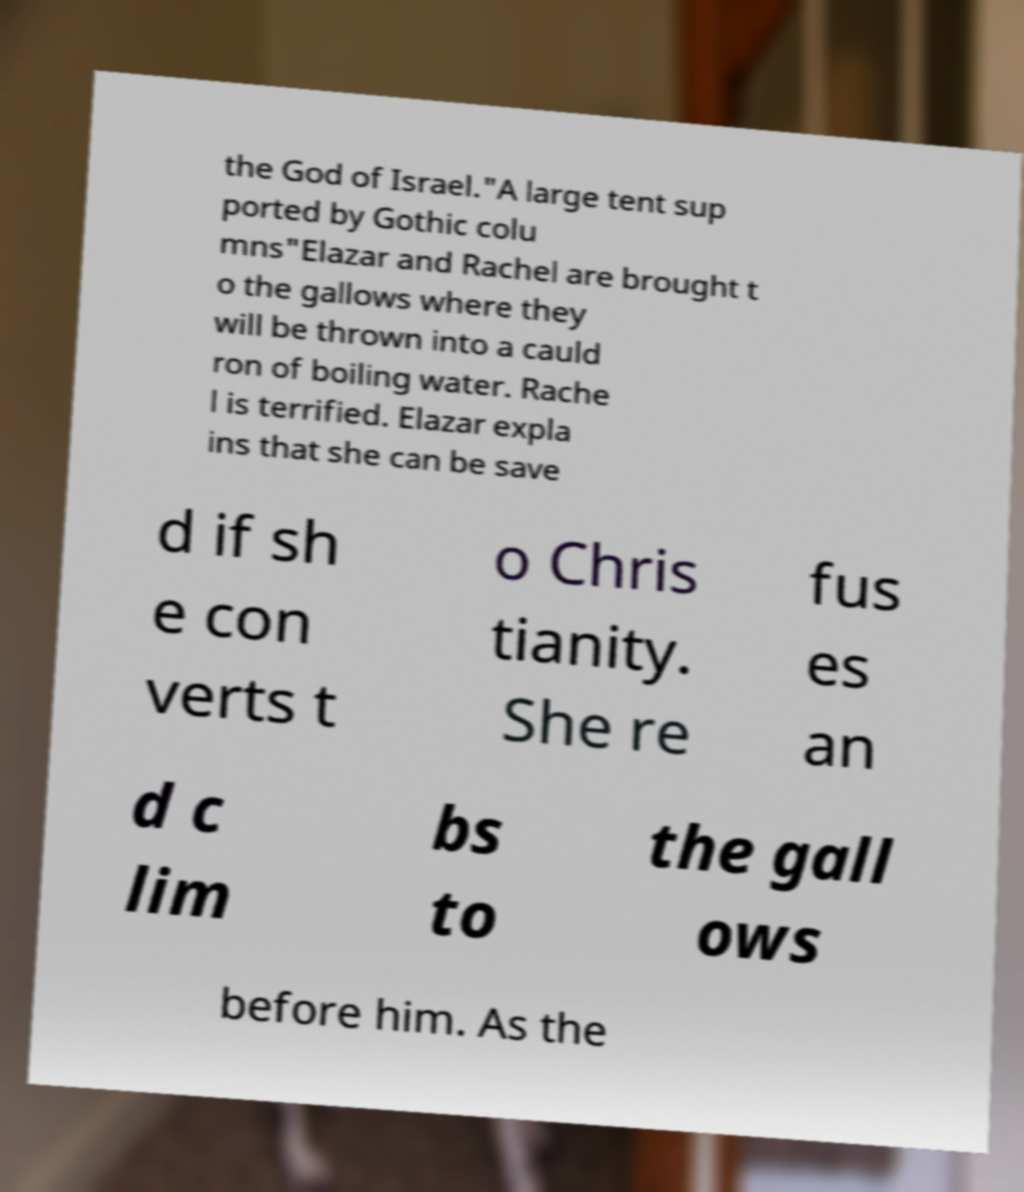There's text embedded in this image that I need extracted. Can you transcribe it verbatim? the God of Israel."A large tent sup ported by Gothic colu mns"Elazar and Rachel are brought t o the gallows where they will be thrown into a cauld ron of boiling water. Rache l is terrified. Elazar expla ins that she can be save d if sh e con verts t o Chris tianity. She re fus es an d c lim bs to the gall ows before him. As the 